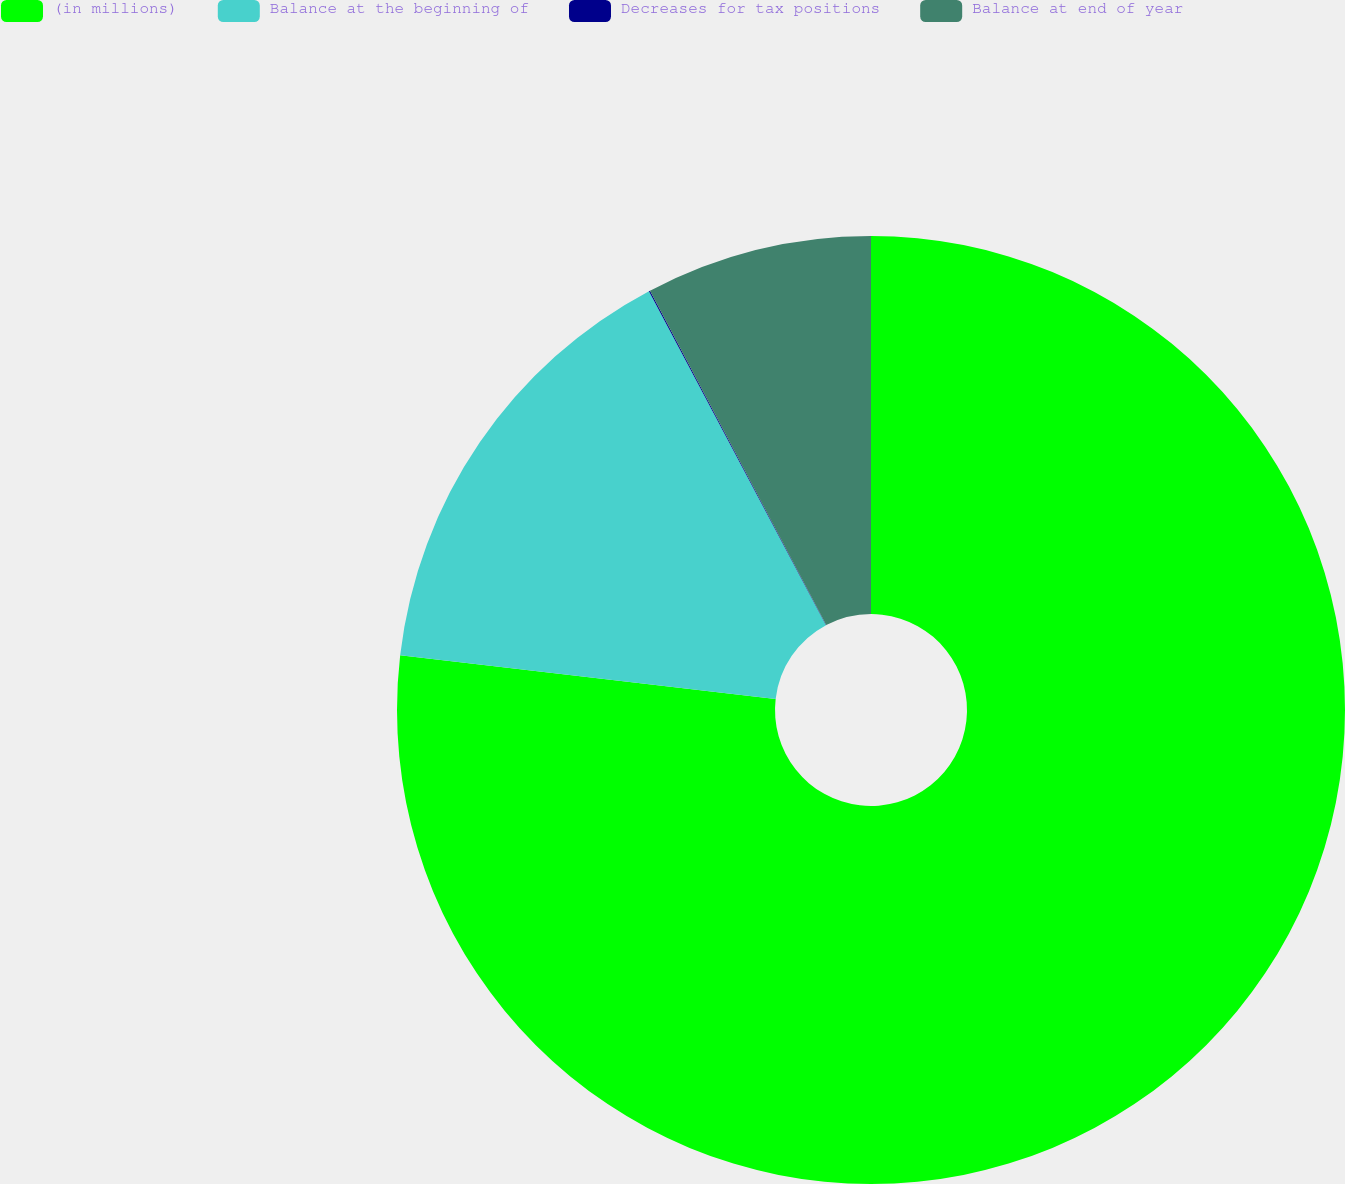Convert chart. <chart><loc_0><loc_0><loc_500><loc_500><pie_chart><fcel>(in millions)<fcel>Balance at the beginning of<fcel>Decreases for tax positions<fcel>Balance at end of year<nl><fcel>76.84%<fcel>15.4%<fcel>0.04%<fcel>7.72%<nl></chart> 